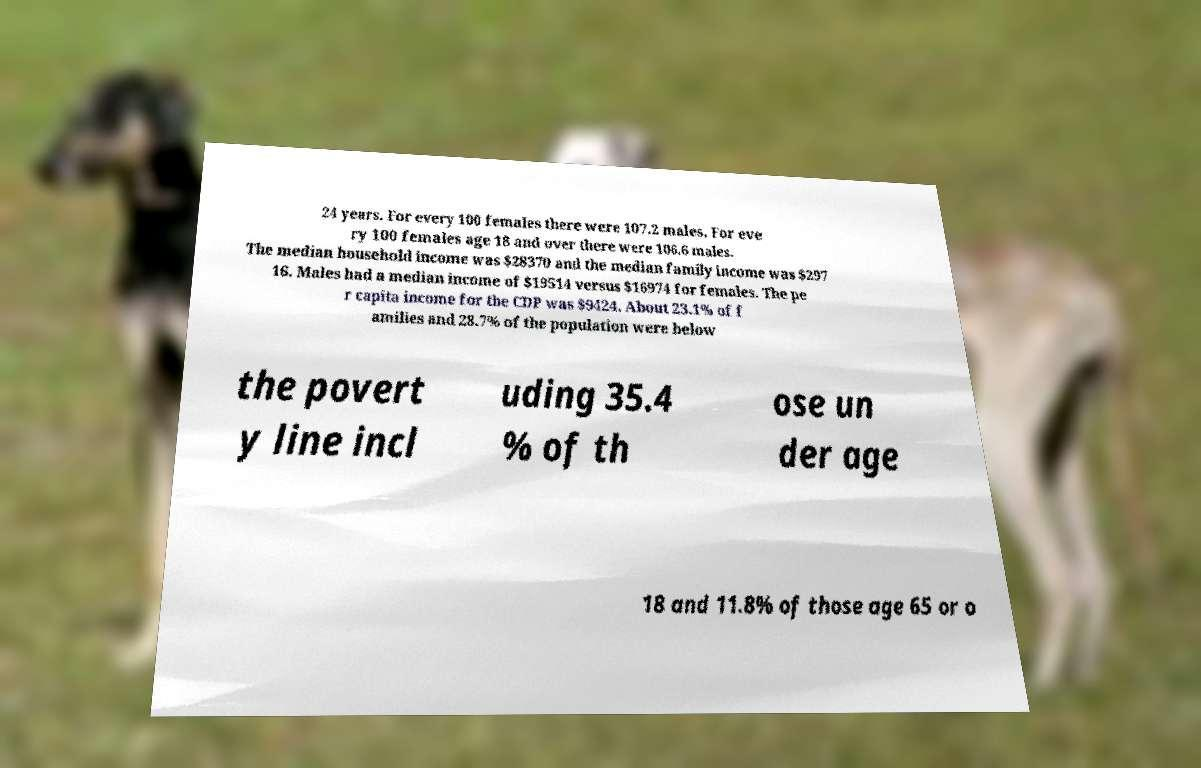Could you assist in decoding the text presented in this image and type it out clearly? 24 years. For every 100 females there were 107.2 males. For eve ry 100 females age 18 and over there were 106.6 males. The median household income was $28370 and the median family income was $297 16. Males had a median income of $19514 versus $16974 for females. The pe r capita income for the CDP was $9424. About 23.1% of f amilies and 28.7% of the population were below the povert y line incl uding 35.4 % of th ose un der age 18 and 11.8% of those age 65 or o 